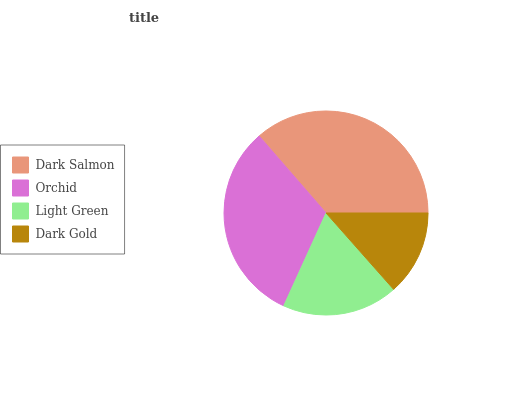Is Dark Gold the minimum?
Answer yes or no. Yes. Is Dark Salmon the maximum?
Answer yes or no. Yes. Is Orchid the minimum?
Answer yes or no. No. Is Orchid the maximum?
Answer yes or no. No. Is Dark Salmon greater than Orchid?
Answer yes or no. Yes. Is Orchid less than Dark Salmon?
Answer yes or no. Yes. Is Orchid greater than Dark Salmon?
Answer yes or no. No. Is Dark Salmon less than Orchid?
Answer yes or no. No. Is Orchid the high median?
Answer yes or no. Yes. Is Light Green the low median?
Answer yes or no. Yes. Is Dark Gold the high median?
Answer yes or no. No. Is Orchid the low median?
Answer yes or no. No. 